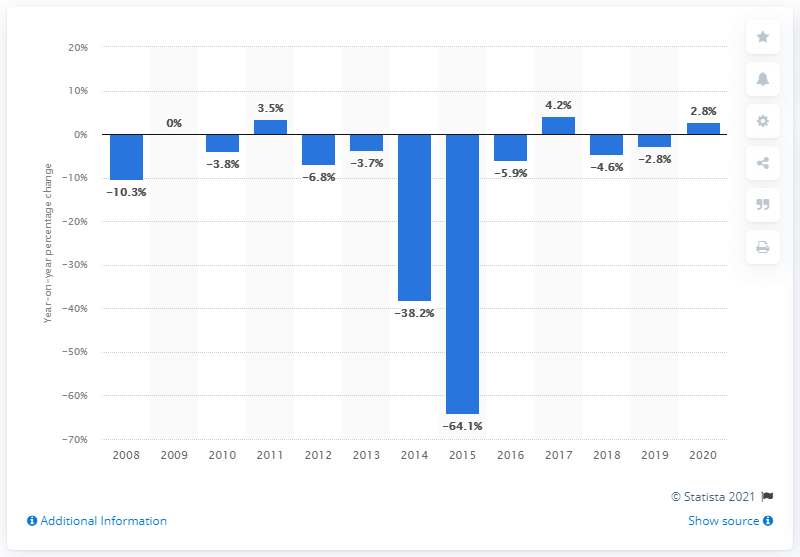Point out several critical features in this image. In 2020, the production of tobacco in the Netherlands increased by 2.8%. 